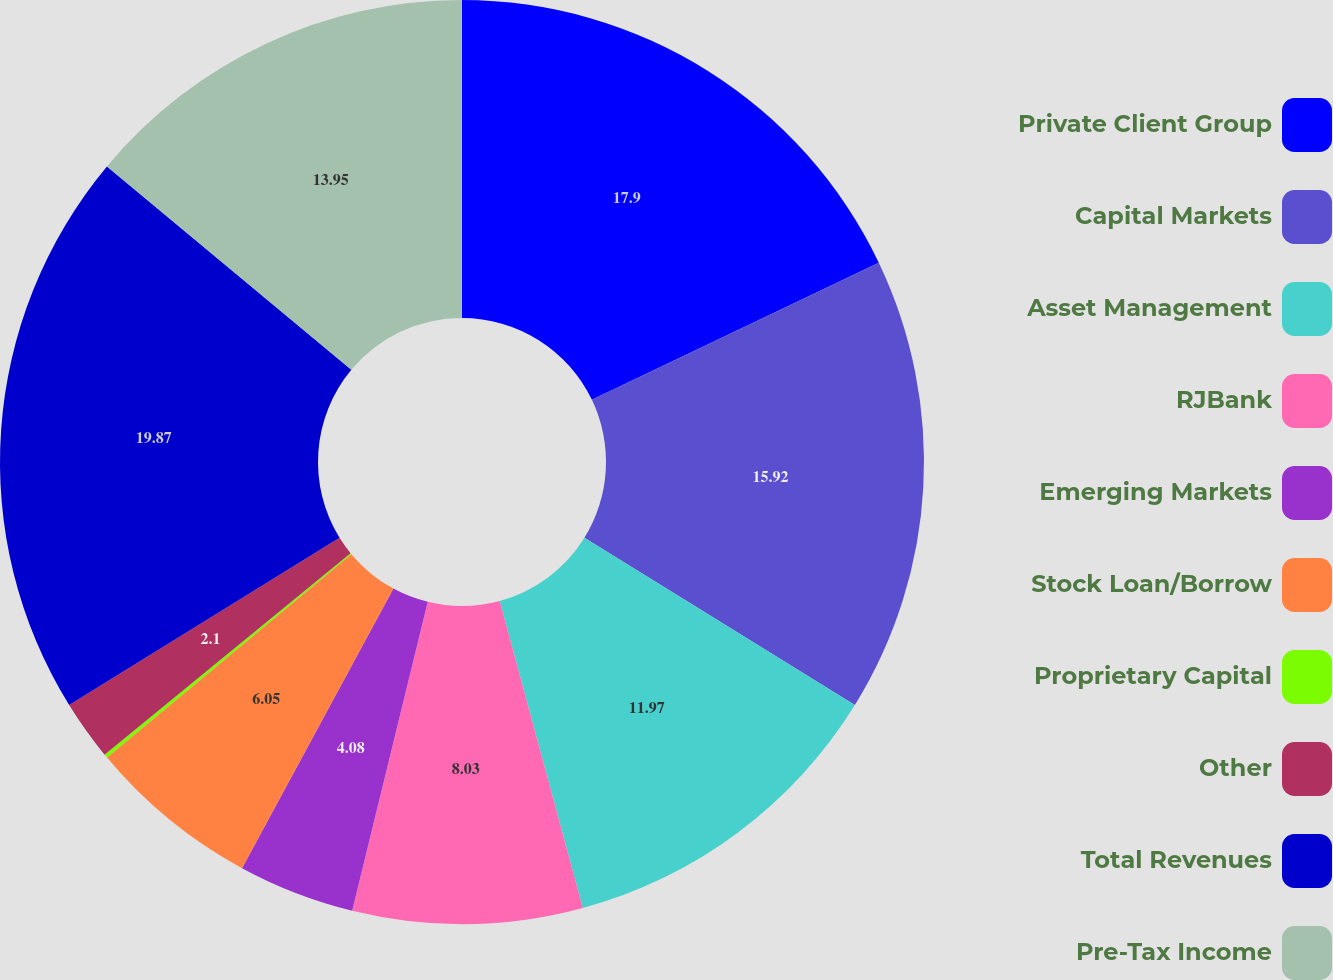Convert chart to OTSL. <chart><loc_0><loc_0><loc_500><loc_500><pie_chart><fcel>Private Client Group<fcel>Capital Markets<fcel>Asset Management<fcel>RJBank<fcel>Emerging Markets<fcel>Stock Loan/Borrow<fcel>Proprietary Capital<fcel>Other<fcel>Total Revenues<fcel>Pre-Tax Income<nl><fcel>17.9%<fcel>15.92%<fcel>11.97%<fcel>8.03%<fcel>4.08%<fcel>6.05%<fcel>0.13%<fcel>2.1%<fcel>19.87%<fcel>13.95%<nl></chart> 